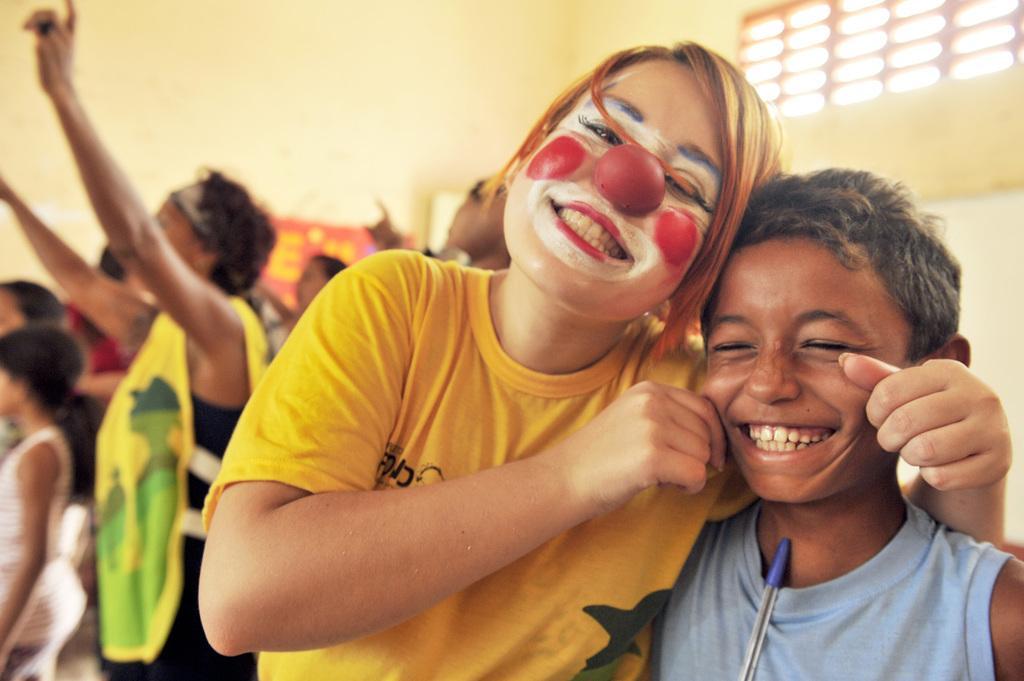How would you summarize this image in a sentence or two? In this picture there is a clown and a boy in the center of the image and there are other people in the background area of the image, there is a window at the top side of the image. 